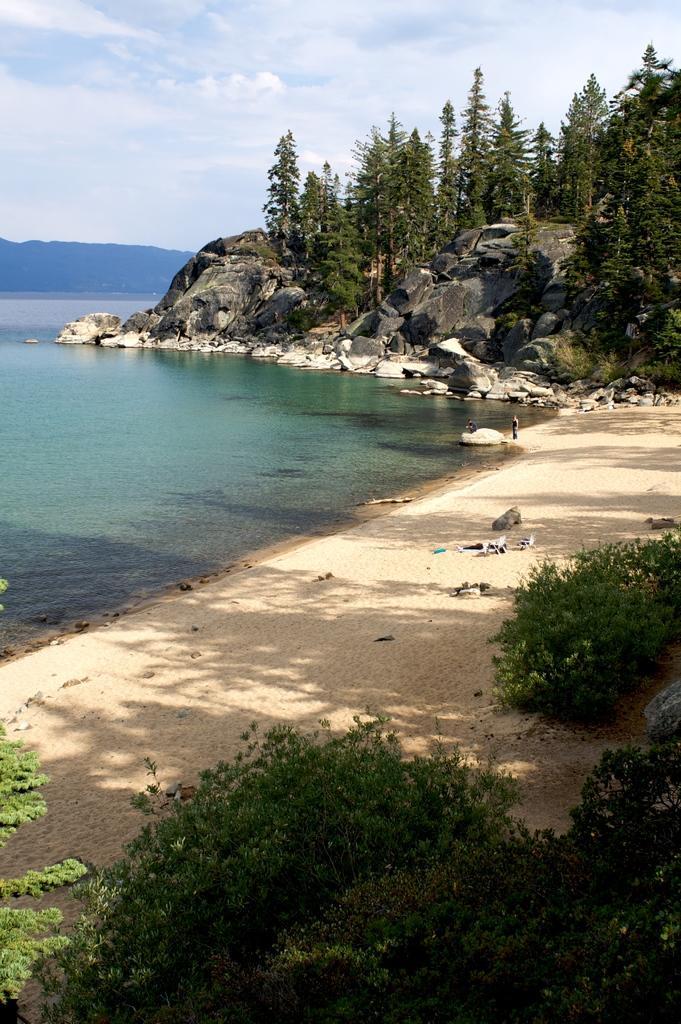How would you summarize this image in a sentence or two? At the bottom of this image, there are trees and plants on the ground. In the background, there is water, there are persons on the sand surface, there are mountains and there are clouds in the sky. 